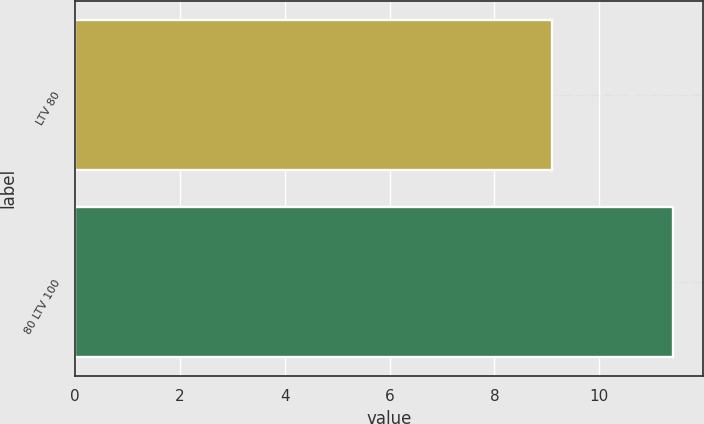<chart> <loc_0><loc_0><loc_500><loc_500><bar_chart><fcel>LTV 80<fcel>80 LTV 100<nl><fcel>9.1<fcel>11.4<nl></chart> 